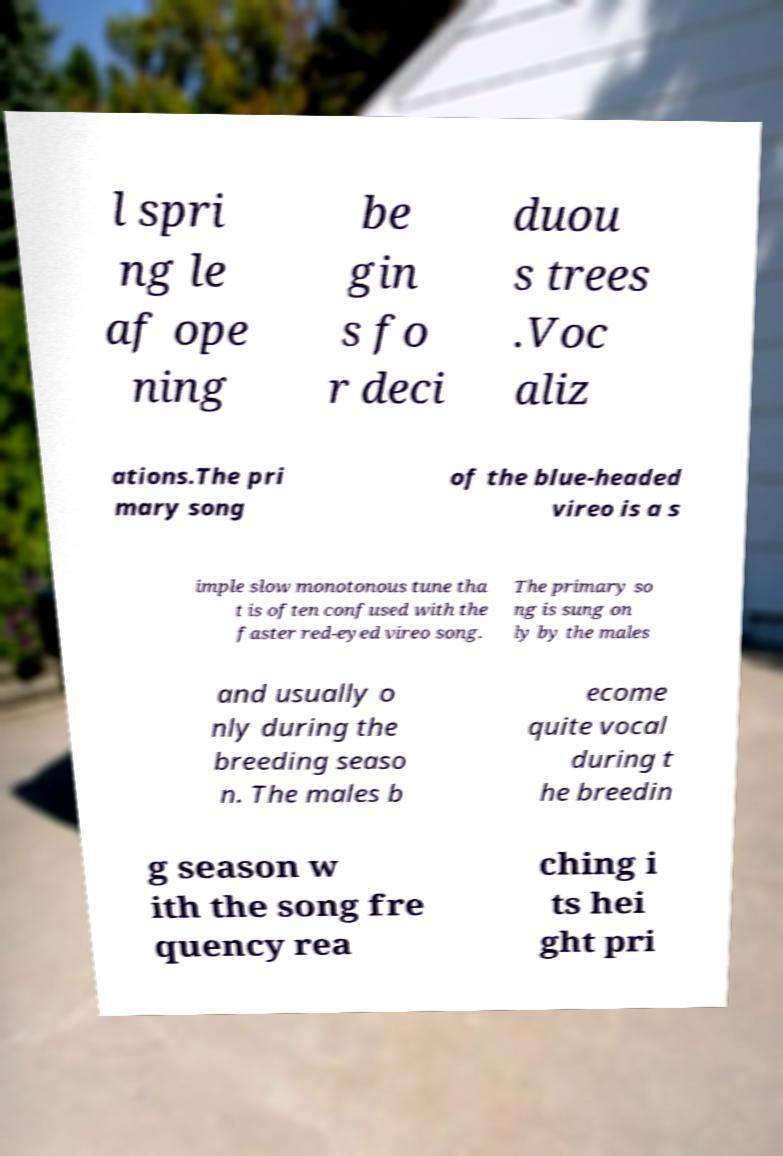What messages or text are displayed in this image? I need them in a readable, typed format. l spri ng le af ope ning be gin s fo r deci duou s trees .Voc aliz ations.The pri mary song of the blue-headed vireo is a s imple slow monotonous tune tha t is often confused with the faster red-eyed vireo song. The primary so ng is sung on ly by the males and usually o nly during the breeding seaso n. The males b ecome quite vocal during t he breedin g season w ith the song fre quency rea ching i ts hei ght pri 